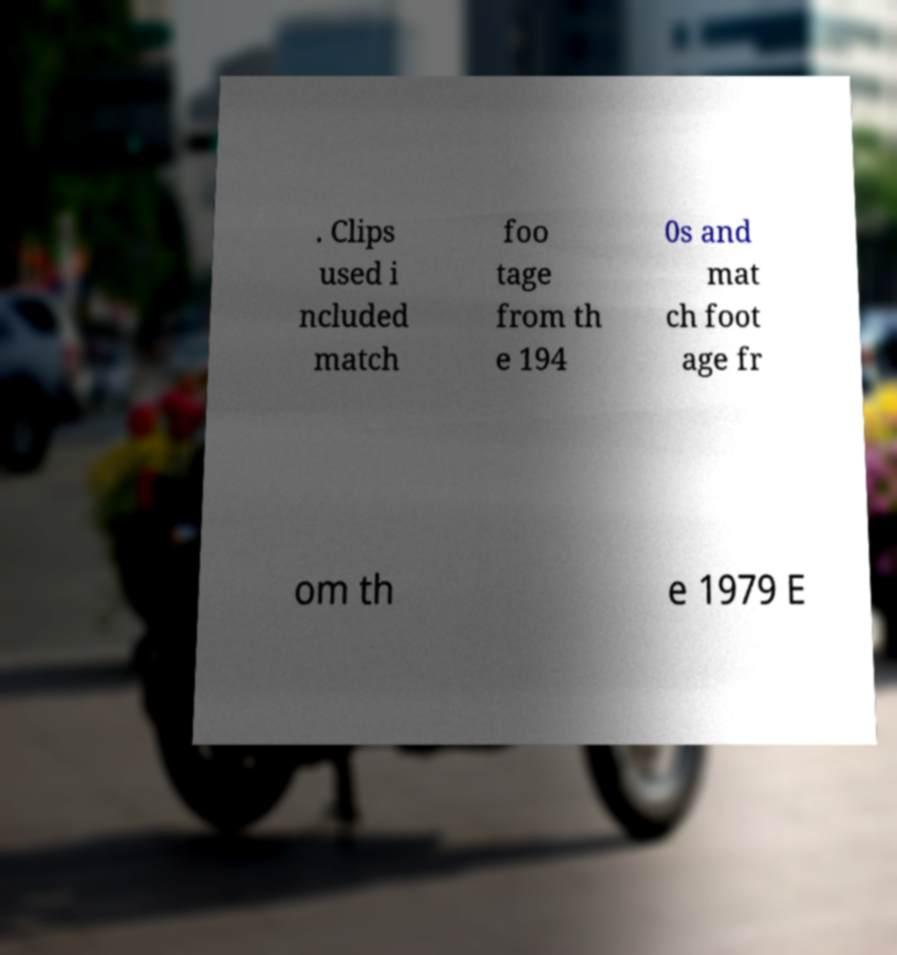I need the written content from this picture converted into text. Can you do that? . Clips used i ncluded match foo tage from th e 194 0s and mat ch foot age fr om th e 1979 E 